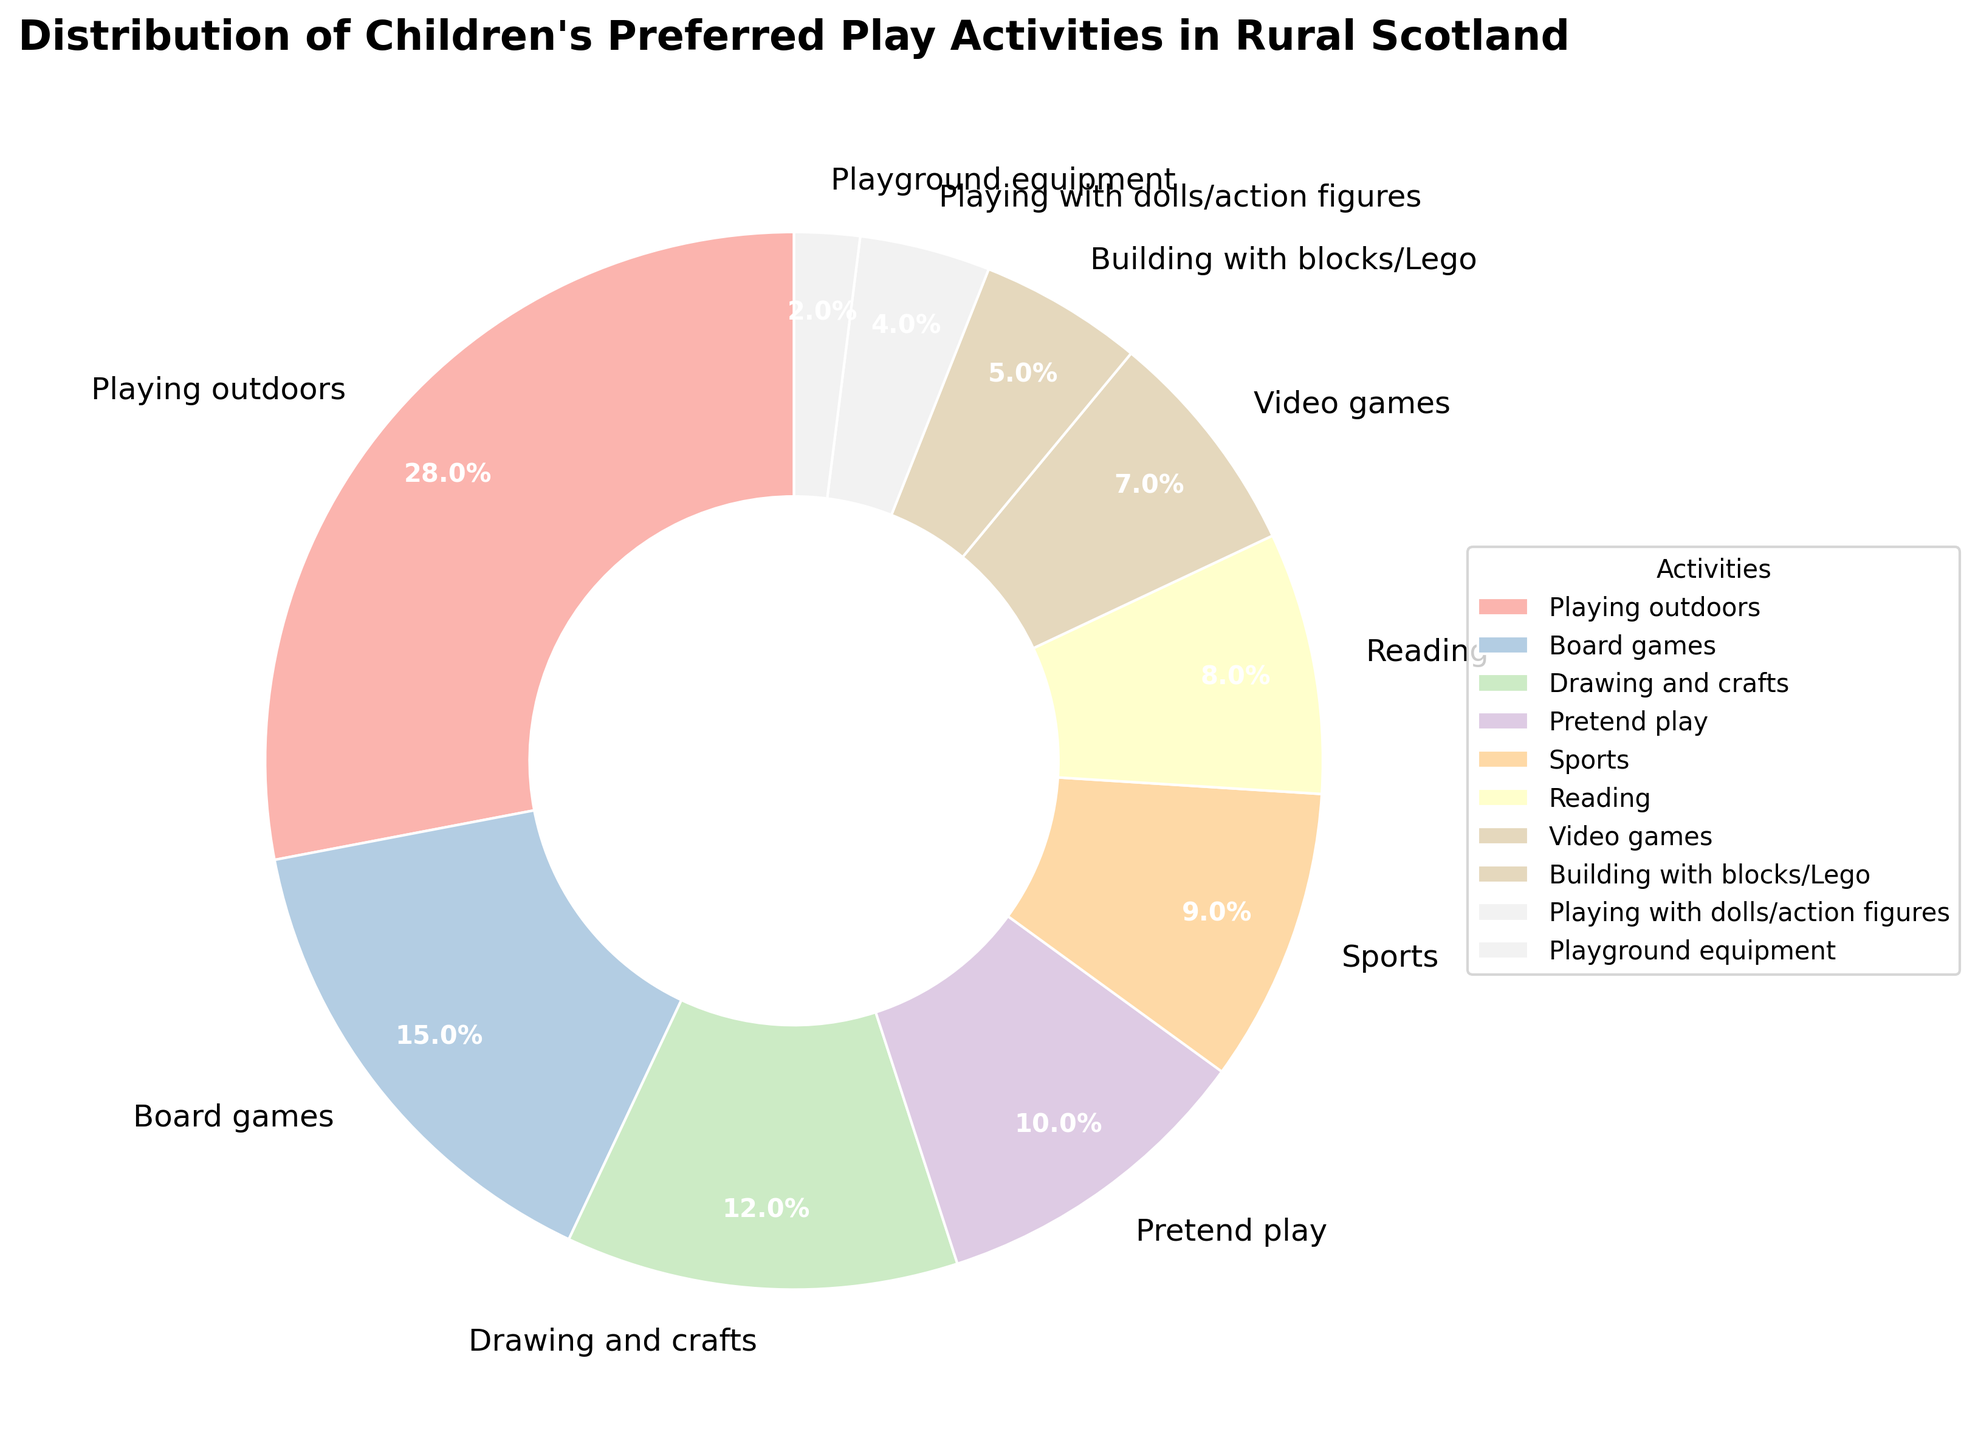Which activity is preferred the most by children in rural Scotland? The largest wedge in the pie chart represents the activity with the highest percentage. The slice for "Playing outdoors" is the largest.
Answer: Playing outdoors Which two activities have the smallest preference among children in rural Scotland? The two smallest wedges in the pie chart represent the activities with the lowest percentages. They are "Playground equipment" and "Playing with dolls/action figures."
Answer: Playground equipment and Playing with dolls/action figures What is the combined percentage of children who prefer playing outdoors and playing sports? Find the wedges for "Playing outdoors" and "Sports" and sum their percentages: 28% + 9% = 37%.
Answer: 37% How many activities have a preference percentage greater than 10%? Count the number of wedges which have associated percentages greater than 10%. These activities are "Playing outdoors", "Board games", "Drawing and crafts", and "Pretend play", totaling 4.
Answer: 4 Which activities have a preference percentage that is below the median percentage of all listed activities? The median of the percentage values is 8.5%. The activities below this median are "Reading", "Video games", "Building with blocks/Lego", "Playing with dolls/action figures", and "Playground equipment."
Answer: Reading, Video games, Building with blocks/Lego, Playing with dolls/action figures, Playground equipment What is the difference in preference percentage between board games and video games? The percentages for board games and video games are 15% and 7% respectively. The difference is 15% - 7% = 8%.
Answer: 8% Which activity has a preference percentage closest to the average preference percentage of all the activities? Calculate the average of all percentages: (28 + 15 + 12 + 10 + 9 + 8 + 7 + 5 + 4 + 2) / 10 = 10%. The activity closest to this average is "Pretend play" with 10%.
Answer: Pretend play Are there more children who prefer reading or more children who prefer video games? Compare the wedges for "Reading" and "Video games." The "Reading" slice is 8%, while "Video games" is 7%. Thus, more children prefer reading.
Answer: Reading 